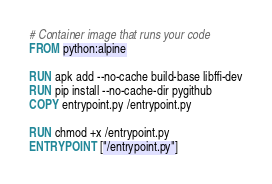Convert code to text. <code><loc_0><loc_0><loc_500><loc_500><_Dockerfile_># Container image that runs your code
FROM python:alpine

RUN apk add --no-cache build-base libffi-dev
RUN pip install --no-cache-dir pygithub
COPY entrypoint.py /entrypoint.py

RUN chmod +x /entrypoint.py
ENTRYPOINT ["/entrypoint.py"]
</code> 